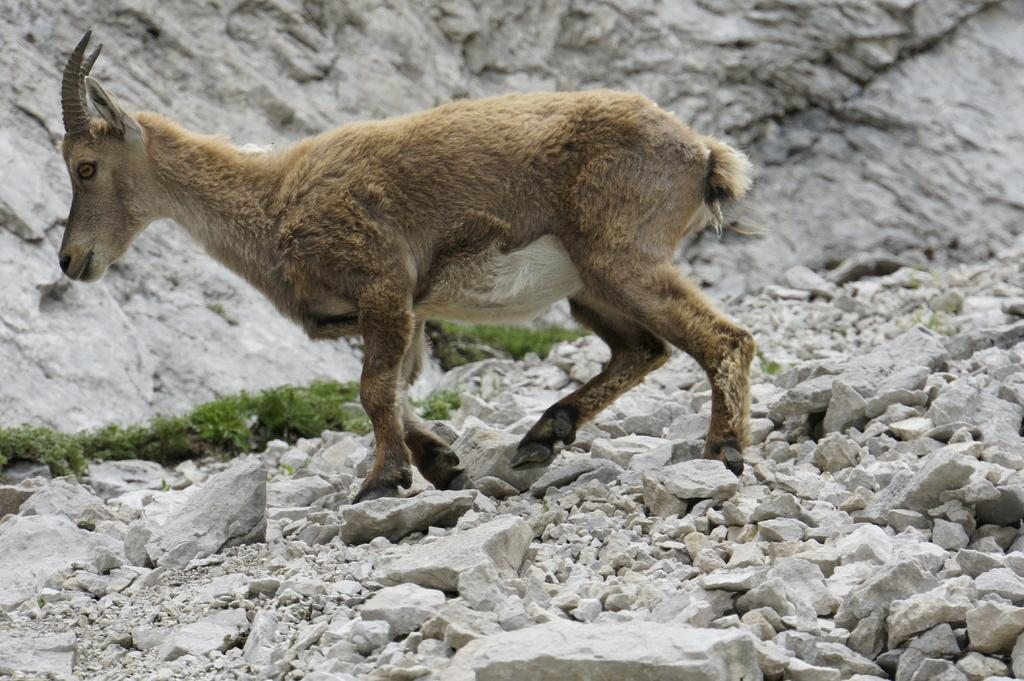What type of animal can be seen in the image? There is an animal in the image, but its specific type cannot be determined from the provided facts. What is the animal doing in the image? The animal is walking on a rock surface. What type of terrain is visible in the image? There is grass visible in the image, as well as a rock surface. What type of structure is present in the image? There is a rock wall in the image. Is the animal seeking shelter from the rainstorm in the image? There is no mention of a rainstorm in the image, so it cannot be determined if the animal is seeking shelter. 